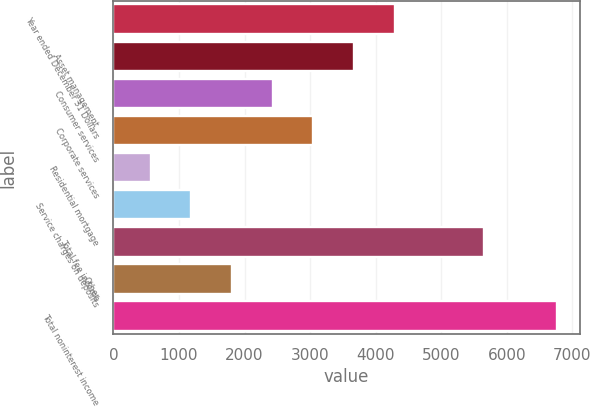<chart> <loc_0><loc_0><loc_500><loc_500><bar_chart><fcel>Year ended December 31 Dollars<fcel>Asset management<fcel>Consumer services<fcel>Corporate services<fcel>Residential mortgage<fcel>Service charges on deposits<fcel>Total fee income<fcel>Other<fcel>Total noninterest income<nl><fcel>4289.4<fcel>3669<fcel>2428.2<fcel>3048.6<fcel>567<fcel>1187.4<fcel>5647<fcel>1807.8<fcel>6771<nl></chart> 